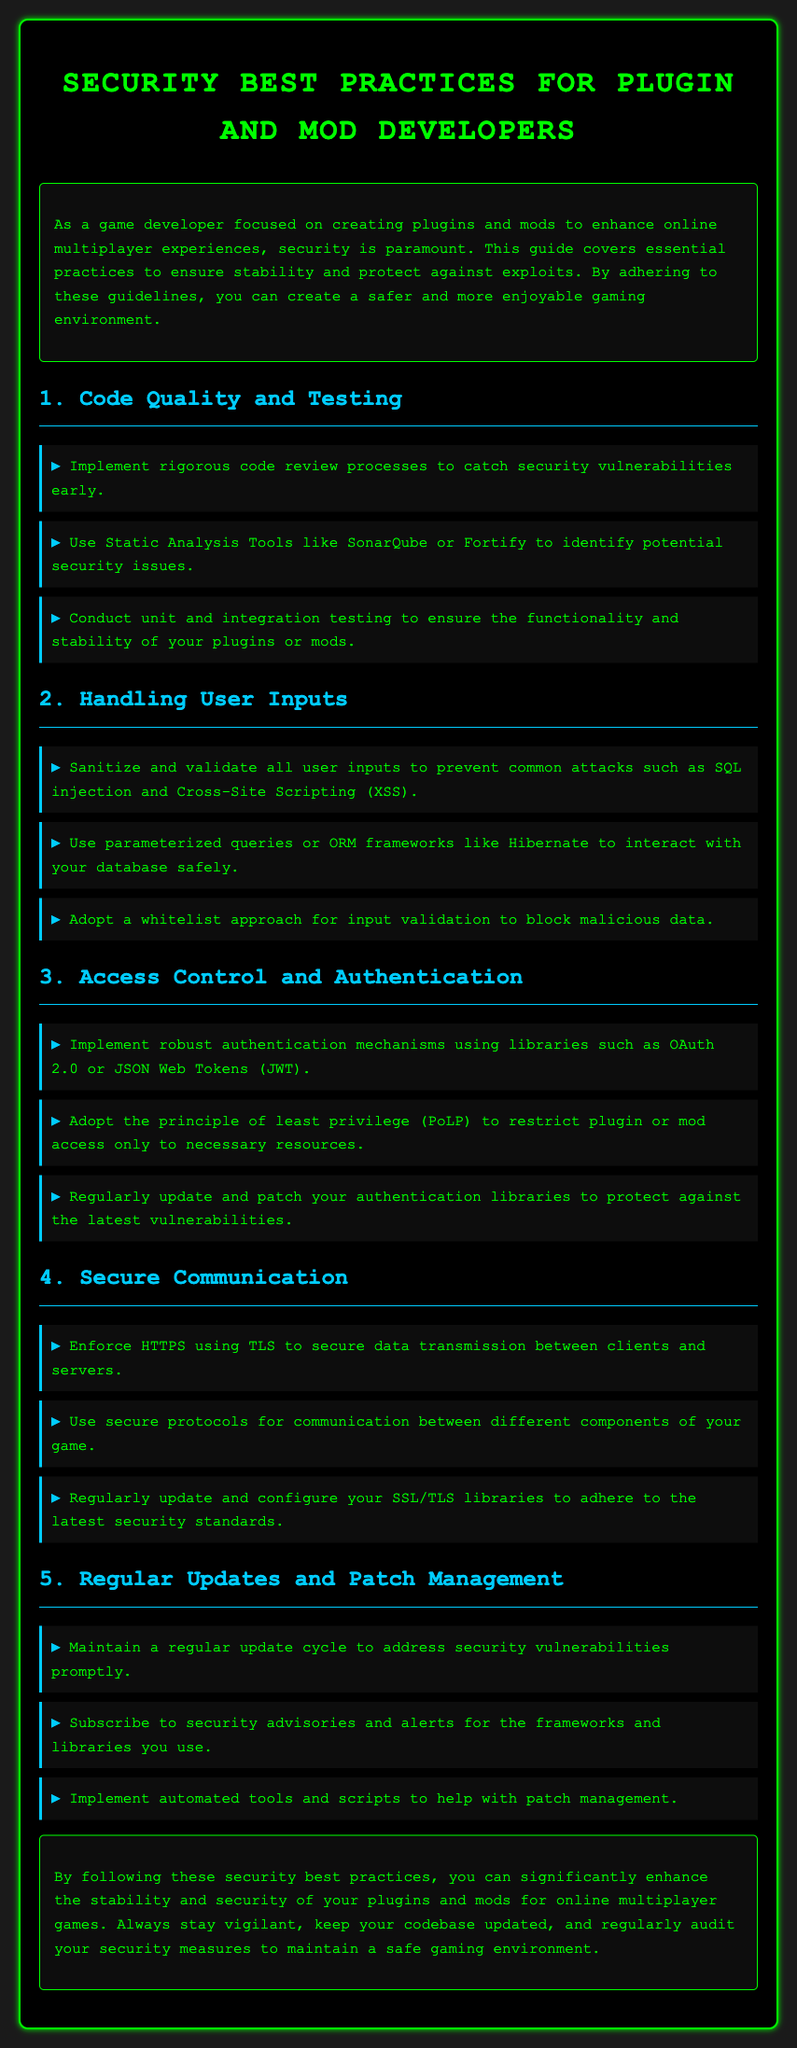What is the main focus of the guide? The guide discusses essential practices for plugin and mod developers to ensure security and stability in multiplayer environments.
Answer: Security best practices How many sections are there in the document? The document covers five main sections detailing various security practices.
Answer: Five Which tool is suggested for Static Analysis? The guide recommends the use of specific tools to identify security issues in the code.
Answer: SonarQube What principle should be adopted for access control? The document emphasizes a specific principle to limit resource access for plugins or mods.
Answer: Principle of least privilege What is emphasized for user input handling? The guide outlines a specific approach to prevent attacks related to user inputs.
Answer: Sanitize and validate Which library is recommended for authentication? A specific library is suggested for implementing robust authentication mechanisms in plugins and mods.
Answer: OAuth 2.0 What is the suggested method for securing communication? The guide recommends a specific protocol to use for secure data transmission between clients and servers.
Answer: HTTPS How often should updates be maintained? The document highlights the need for a specific cycle concerning updates for security vulnerabilities.
Answer: Regularly What should developers subscribe to for security updates? The document advises developers to keep informed about security vulnerabilities through specific resources.
Answer: Security advisories 